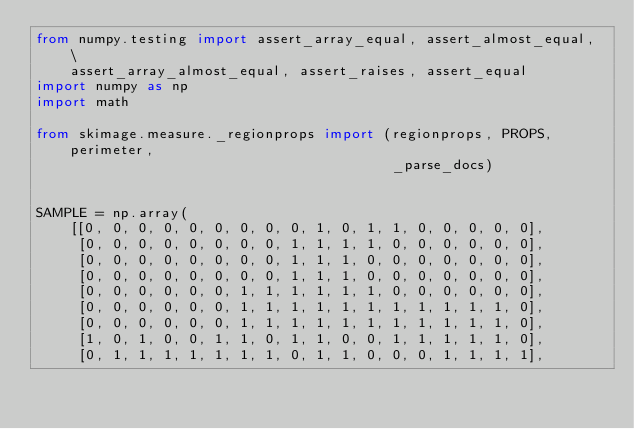<code> <loc_0><loc_0><loc_500><loc_500><_Python_>from numpy.testing import assert_array_equal, assert_almost_equal, \
    assert_array_almost_equal, assert_raises, assert_equal
import numpy as np
import math

from skimage.measure._regionprops import (regionprops, PROPS, perimeter,
                                          _parse_docs)


SAMPLE = np.array(
    [[0, 0, 0, 0, 0, 0, 0, 0, 0, 1, 0, 1, 1, 0, 0, 0, 0, 0],
     [0, 0, 0, 0, 0, 0, 0, 0, 1, 1, 1, 1, 0, 0, 0, 0, 0, 0],
     [0, 0, 0, 0, 0, 0, 0, 0, 1, 1, 1, 0, 0, 0, 0, 0, 0, 0],
     [0, 0, 0, 0, 0, 0, 0, 0, 1, 1, 1, 0, 0, 0, 0, 0, 0, 0],
     [0, 0, 0, 0, 0, 0, 1, 1, 1, 1, 1, 1, 0, 0, 0, 0, 0, 0],
     [0, 0, 0, 0, 0, 0, 1, 1, 1, 1, 1, 1, 1, 1, 1, 1, 1, 0],
     [0, 0, 0, 0, 0, 0, 1, 1, 1, 1, 1, 1, 1, 1, 1, 1, 1, 0],
     [1, 0, 1, 0, 0, 1, 1, 0, 1, 1, 0, 0, 1, 1, 1, 1, 1, 0],
     [0, 1, 1, 1, 1, 1, 1, 1, 0, 1, 1, 0, 0, 0, 1, 1, 1, 1],</code> 